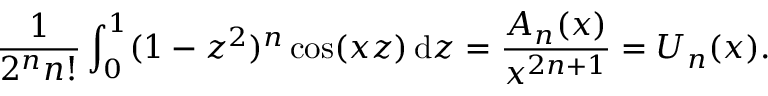Convert formula to latex. <formula><loc_0><loc_0><loc_500><loc_500>{ \frac { 1 } { 2 ^ { n } n ! } } \int _ { 0 } ^ { 1 } ( 1 - z ^ { 2 } ) ^ { n } \cos ( x z ) \, d z = { \frac { A _ { n } ( x ) } { x ^ { 2 n + 1 } } } = U _ { n } ( x ) .</formula> 